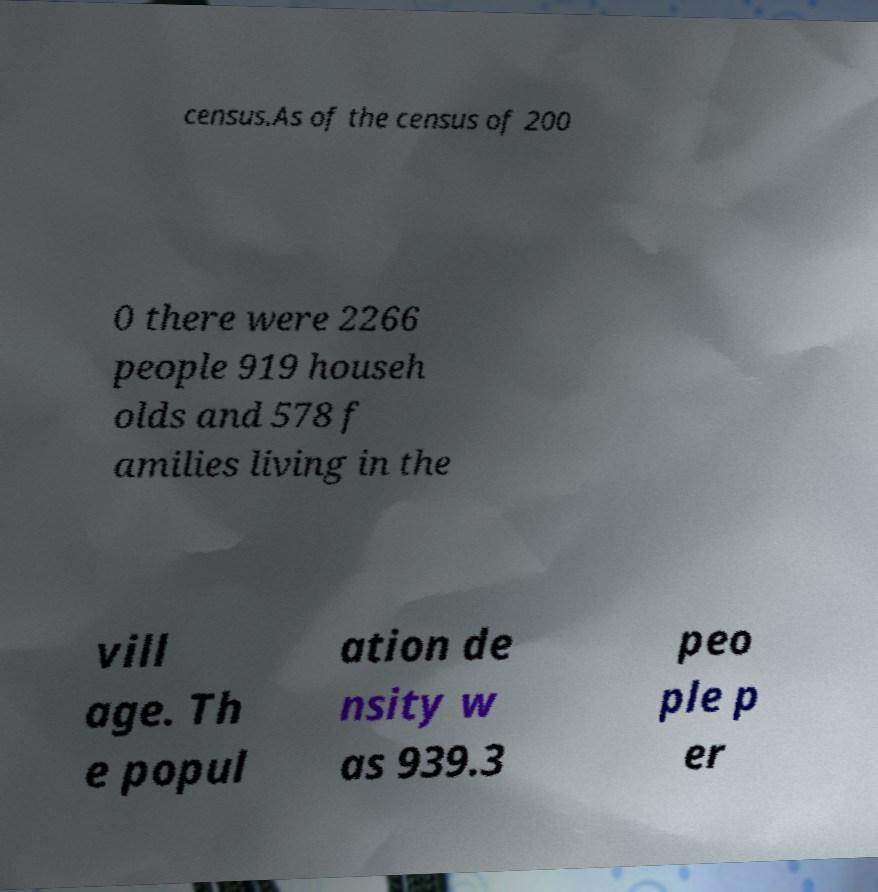Please read and relay the text visible in this image. What does it say? census.As of the census of 200 0 there were 2266 people 919 househ olds and 578 f amilies living in the vill age. Th e popul ation de nsity w as 939.3 peo ple p er 